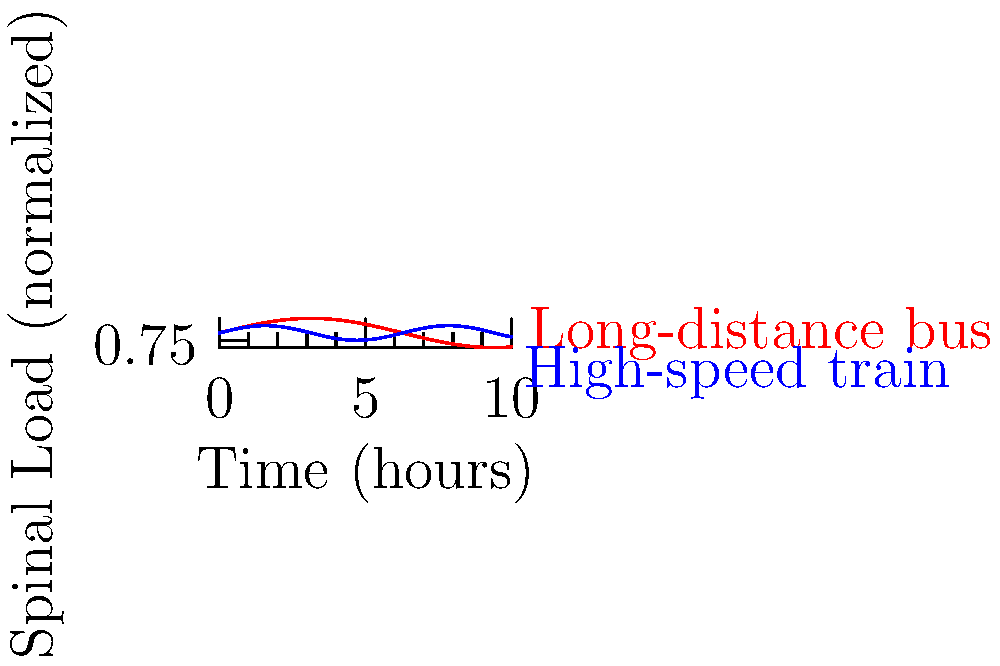Based on the graph comparing spinal load during long-distance bus and high-speed train travel, which mode of transportation generally results in lower biomechanical stress on the spine over an extended journey? To determine which mode of transportation results in lower biomechanical stress on the spine, we need to analyze the graph:

1. The red line represents long-distance bus travel, while the blue line represents high-speed train travel.

2. The y-axis shows the normalized spinal load, where higher values indicate greater stress on the spine.

3. Observe the amplitude of the oscillations:
   - The bus (red line) has larger oscillations, ranging approximately from 0.5 to 1.5.
   - The train (blue line) has smaller oscillations, ranging approximately from 0.75 to 1.25.

4. Calculate the average load:
   - The bus line oscillates around a central value of about 1.
   - The train line also oscillates around a central value of about 1.

5. Compare the overall patterns:
   - The bus line shows more frequent and higher peaks of spinal load.
   - The train line shows more consistent and lower peaks of spinal load.

6. Consider the implications:
   - Lower amplitude oscillations mean less variation in spinal stress.
   - More consistent patterns typically result in less fatigue over time.

Therefore, based on this graph, the high-speed train generally results in lower and more consistent biomechanical stress on the spine over an extended journey.
Answer: High-speed train 